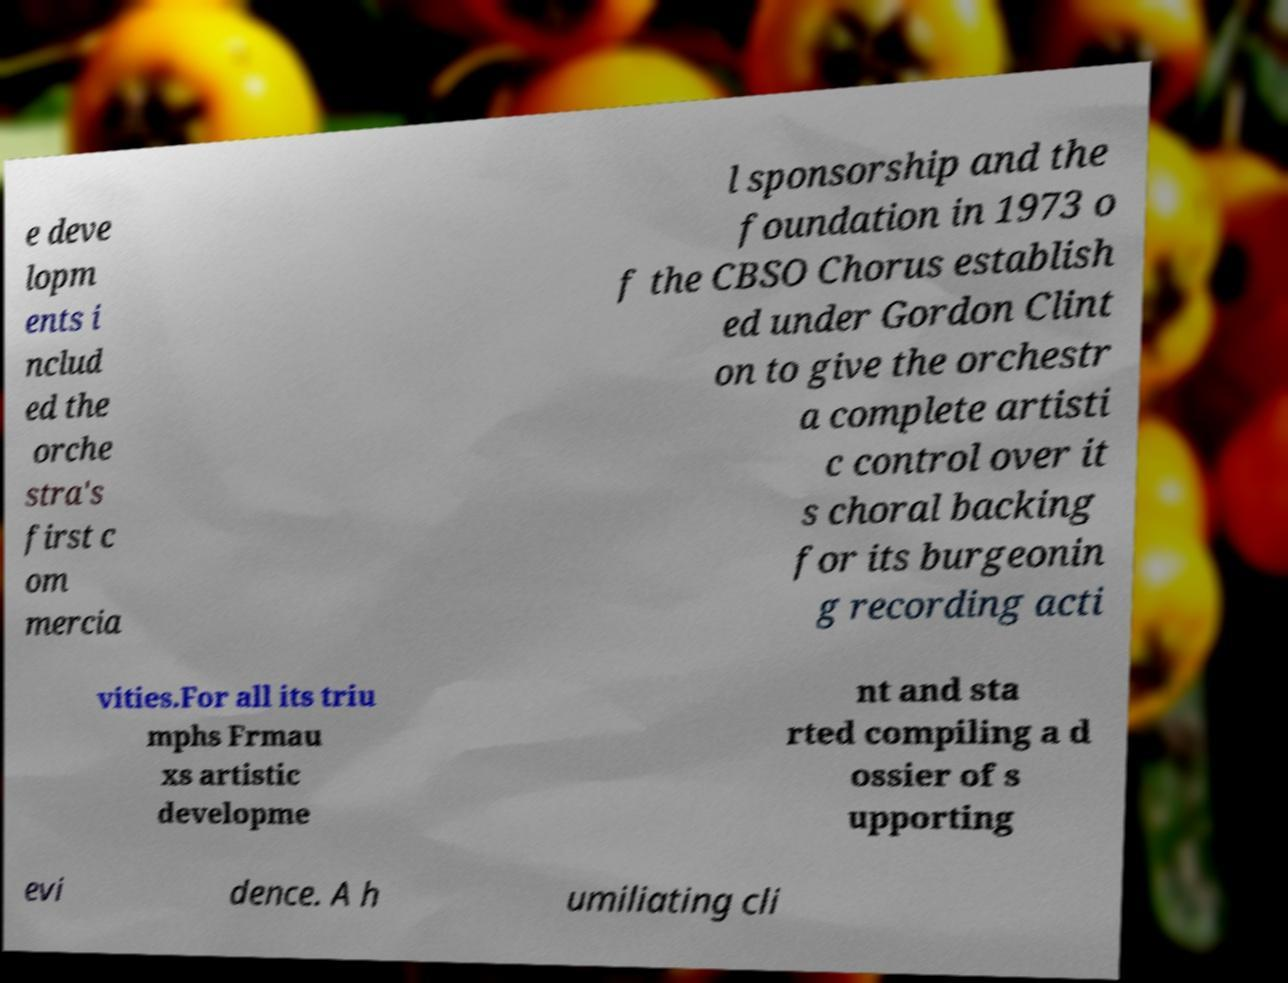For documentation purposes, I need the text within this image transcribed. Could you provide that? e deve lopm ents i nclud ed the orche stra's first c om mercia l sponsorship and the foundation in 1973 o f the CBSO Chorus establish ed under Gordon Clint on to give the orchestr a complete artisti c control over it s choral backing for its burgeonin g recording acti vities.For all its triu mphs Frmau xs artistic developme nt and sta rted compiling a d ossier of s upporting evi dence. A h umiliating cli 